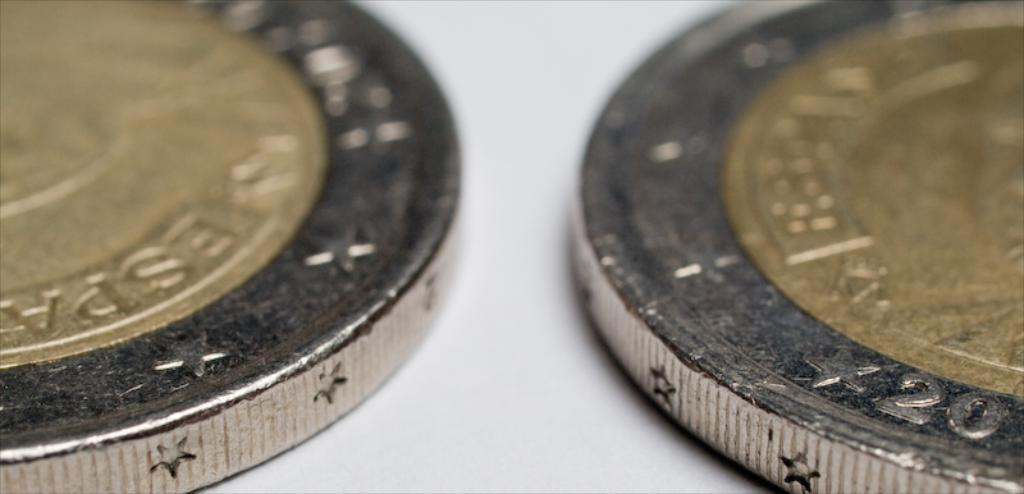<image>
Write a terse but informative summary of the picture. Two gold and silver Espana coins next to each other 